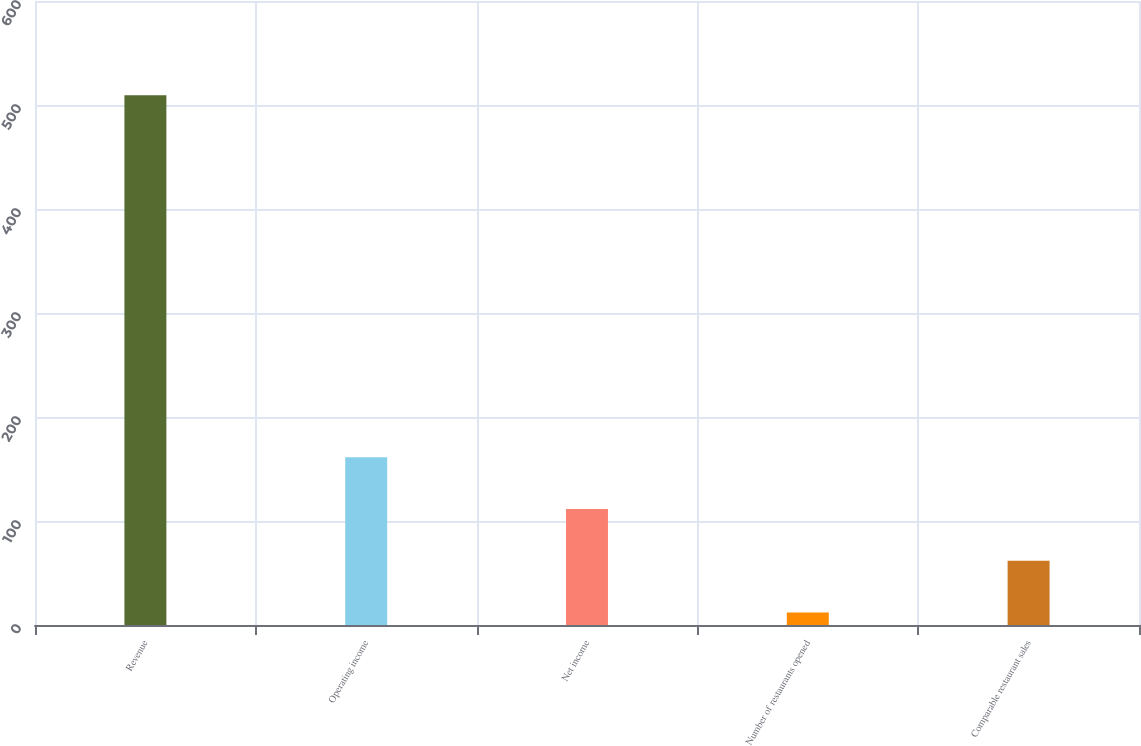<chart> <loc_0><loc_0><loc_500><loc_500><bar_chart><fcel>Revenue<fcel>Operating income<fcel>Net income<fcel>Number of restaurants opened<fcel>Comparable restaurant sales<nl><fcel>509.4<fcel>161.22<fcel>111.48<fcel>12<fcel>61.74<nl></chart> 